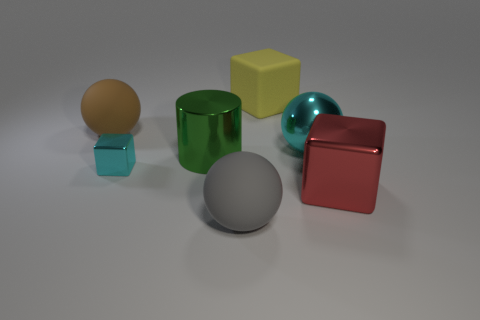Subtract all big metal spheres. How many spheres are left? 2 Add 2 cubes. How many objects exist? 9 Subtract all cyan spheres. How many spheres are left? 2 Subtract 1 spheres. How many spheres are left? 2 Subtract all cylinders. How many objects are left? 6 Subtract all red balls. Subtract all red cylinders. How many balls are left? 3 Add 5 yellow metal cubes. How many yellow metal cubes exist? 5 Subtract 0 green spheres. How many objects are left? 7 Subtract all large red things. Subtract all large cyan balls. How many objects are left? 5 Add 7 cyan shiny blocks. How many cyan shiny blocks are left? 8 